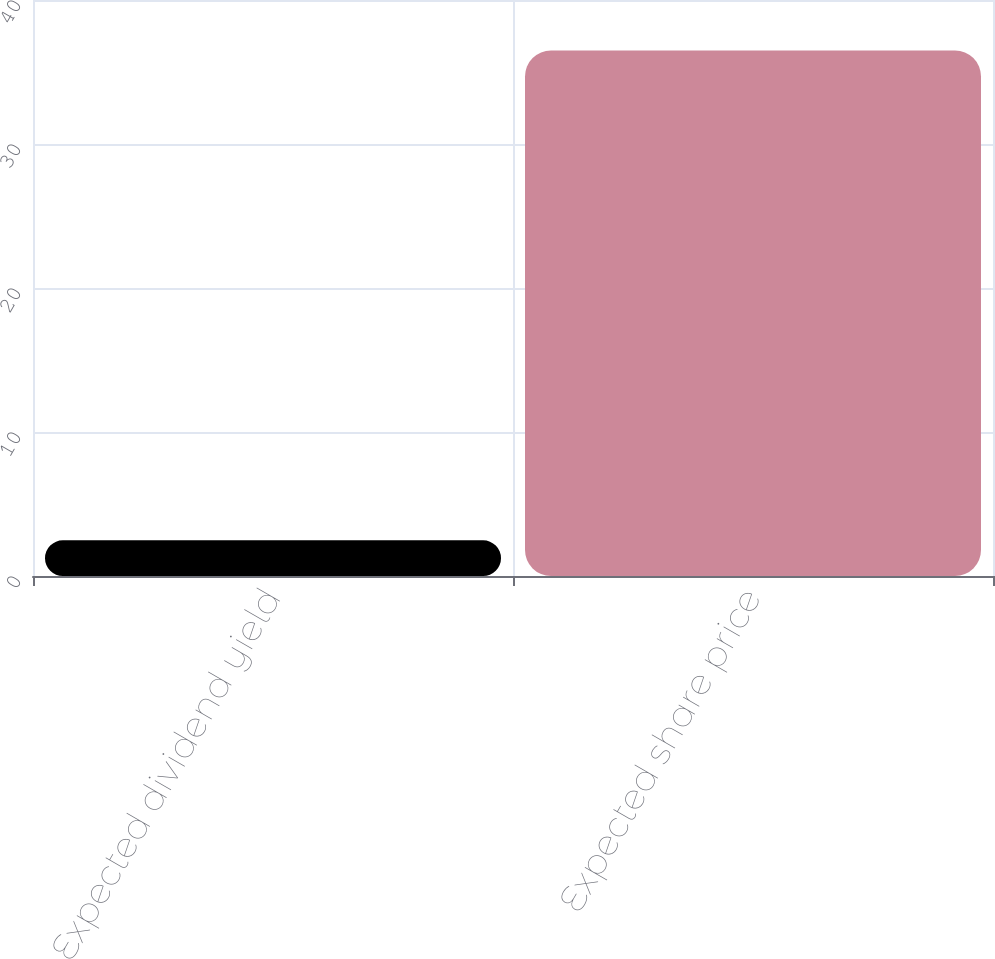Convert chart. <chart><loc_0><loc_0><loc_500><loc_500><bar_chart><fcel>Expected dividend yield<fcel>Expected share price<nl><fcel>2.48<fcel>36.5<nl></chart> 